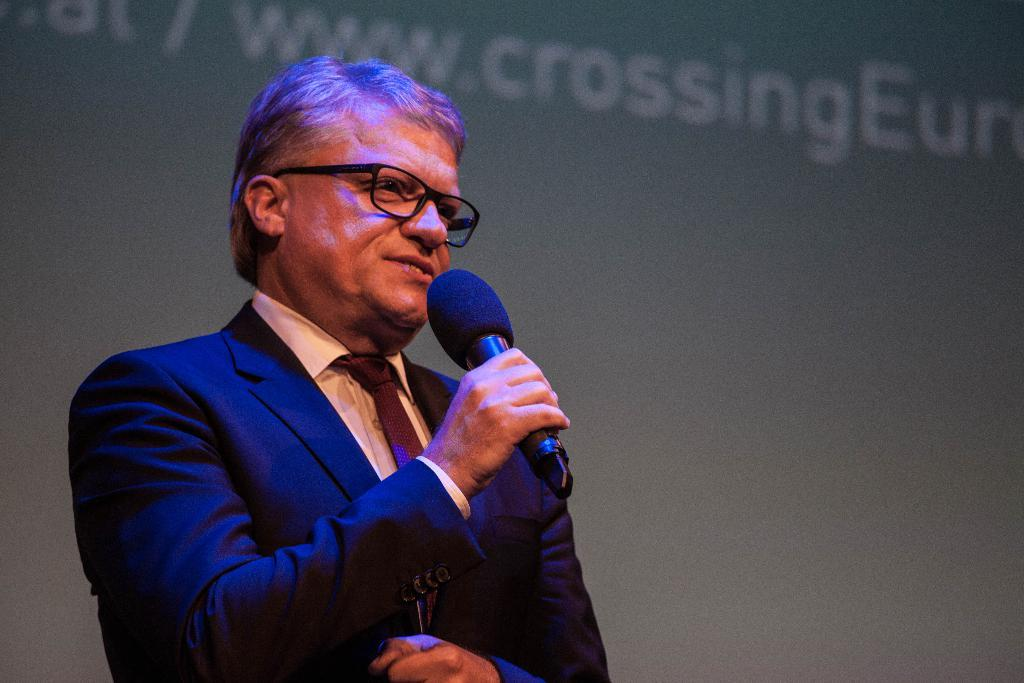What is the main subject of the image? The main subject of the image is a man. What is the man holding in his hand? The man is holding a mic in his hand. What type of winter clothing is the man wearing in the image? There is no indication of winter clothing in the image, as it only shows a man holding a mic in his hand. 